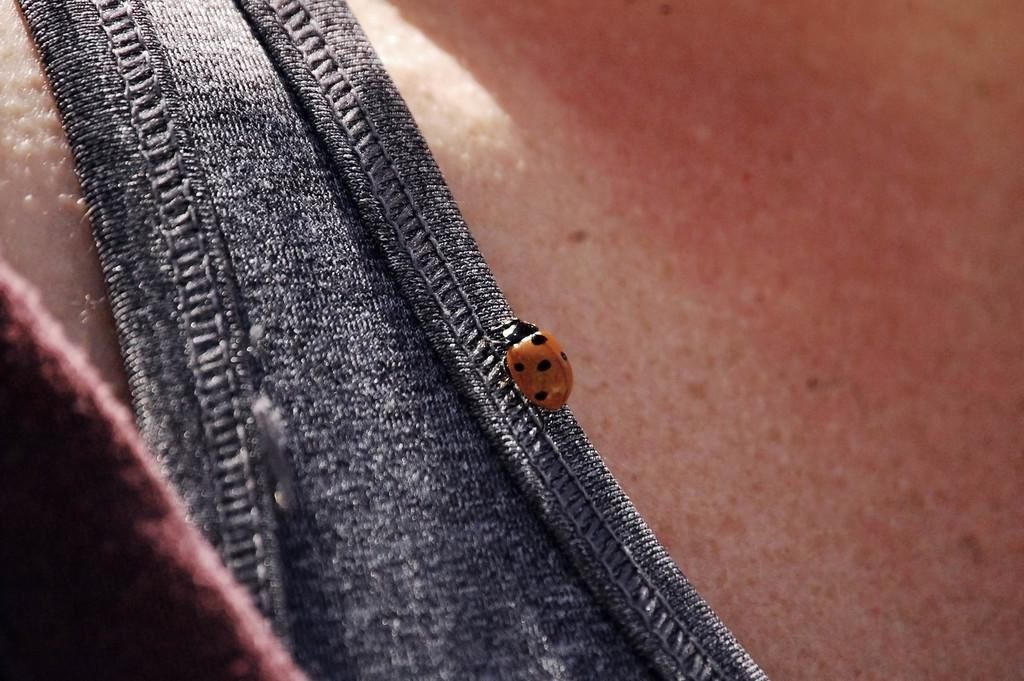What is the main subject of the image? The main subject of the image is a bug. Where is the bug located in the image? The bug is on a cloth. How many rings are the bug wearing in the image? There are no rings visible on the bug in the image. What attempt is the bug making in the image? The bug is not attempting anything in the image; it is simply on the cloth. 